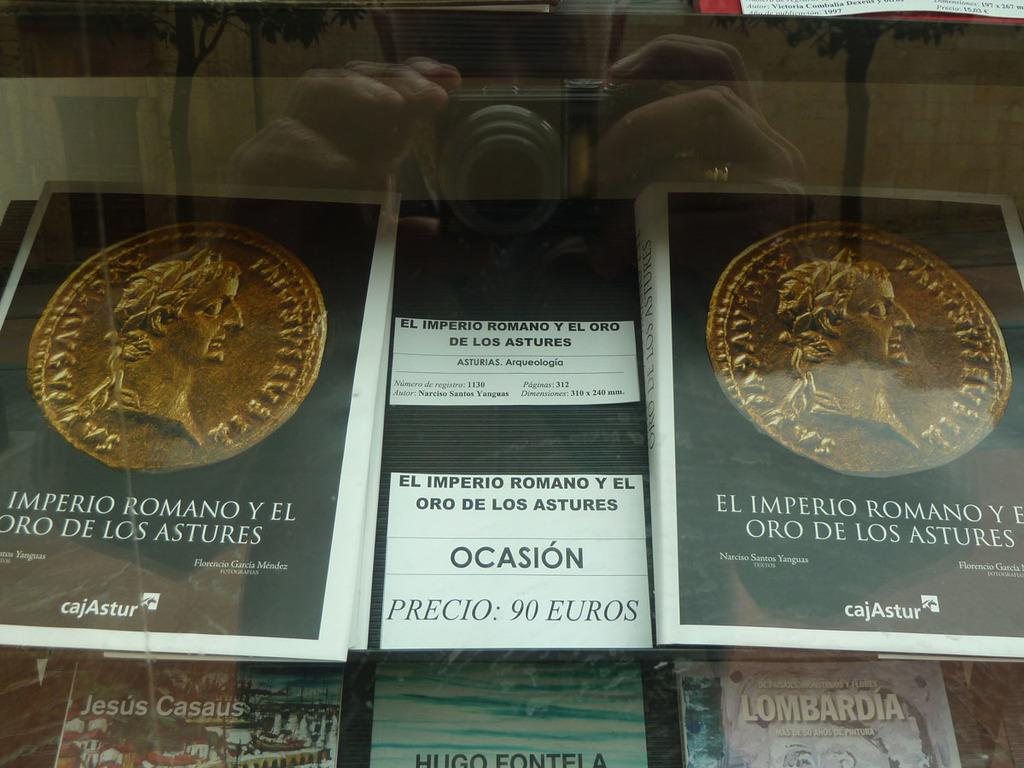Provide a one-sentence caption for the provided image. A display of periodical type items contain a sign with a 90 Euros price tag. 